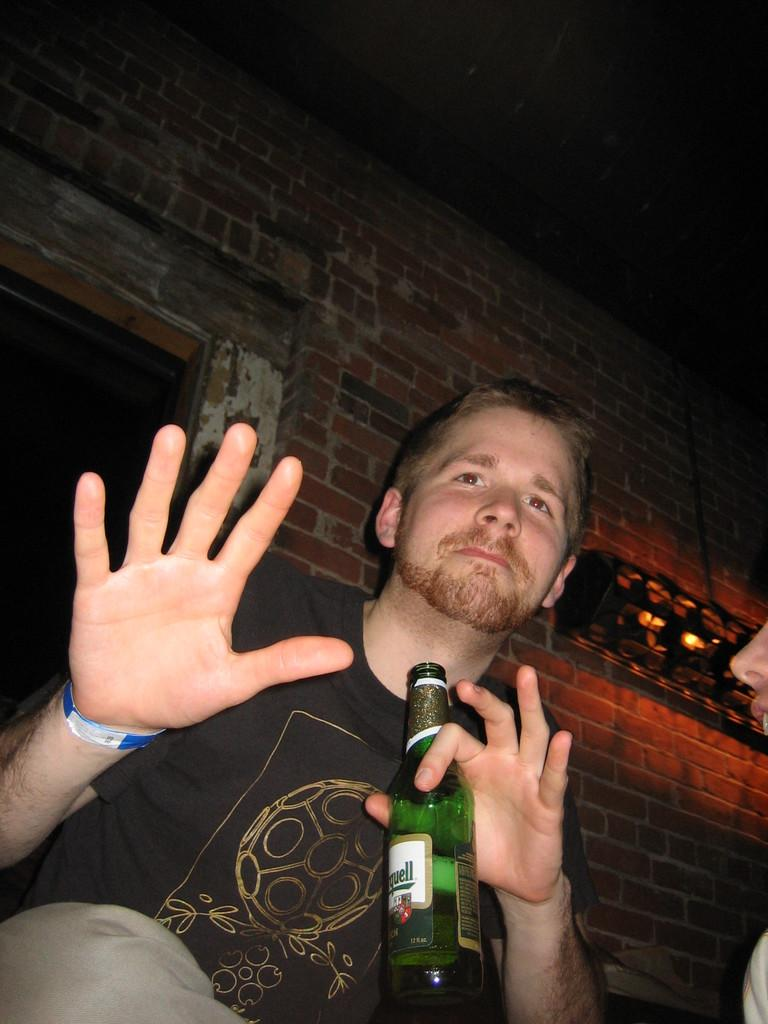Who is the main subject in the image? There is a man in the image. What is the man wearing? The man is wearing a black t-shirt. What is the man doing in the image? The man is sitting. What is the man holding in the image? The man is holding a bottle. What can be seen behind the man? There is a brick wall behind the man. Is there any opening in the brick wall? Yes, there is a door in the brick wall. What type of pest can be seen crawling on the man's shoulder in the image? There are no pests visible on the man's shoulder in the image. Who is the owner of the bottle the man is holding in the image? The facts provided do not mention any ownership of the bottle, so it cannot be determined who the owner is. 